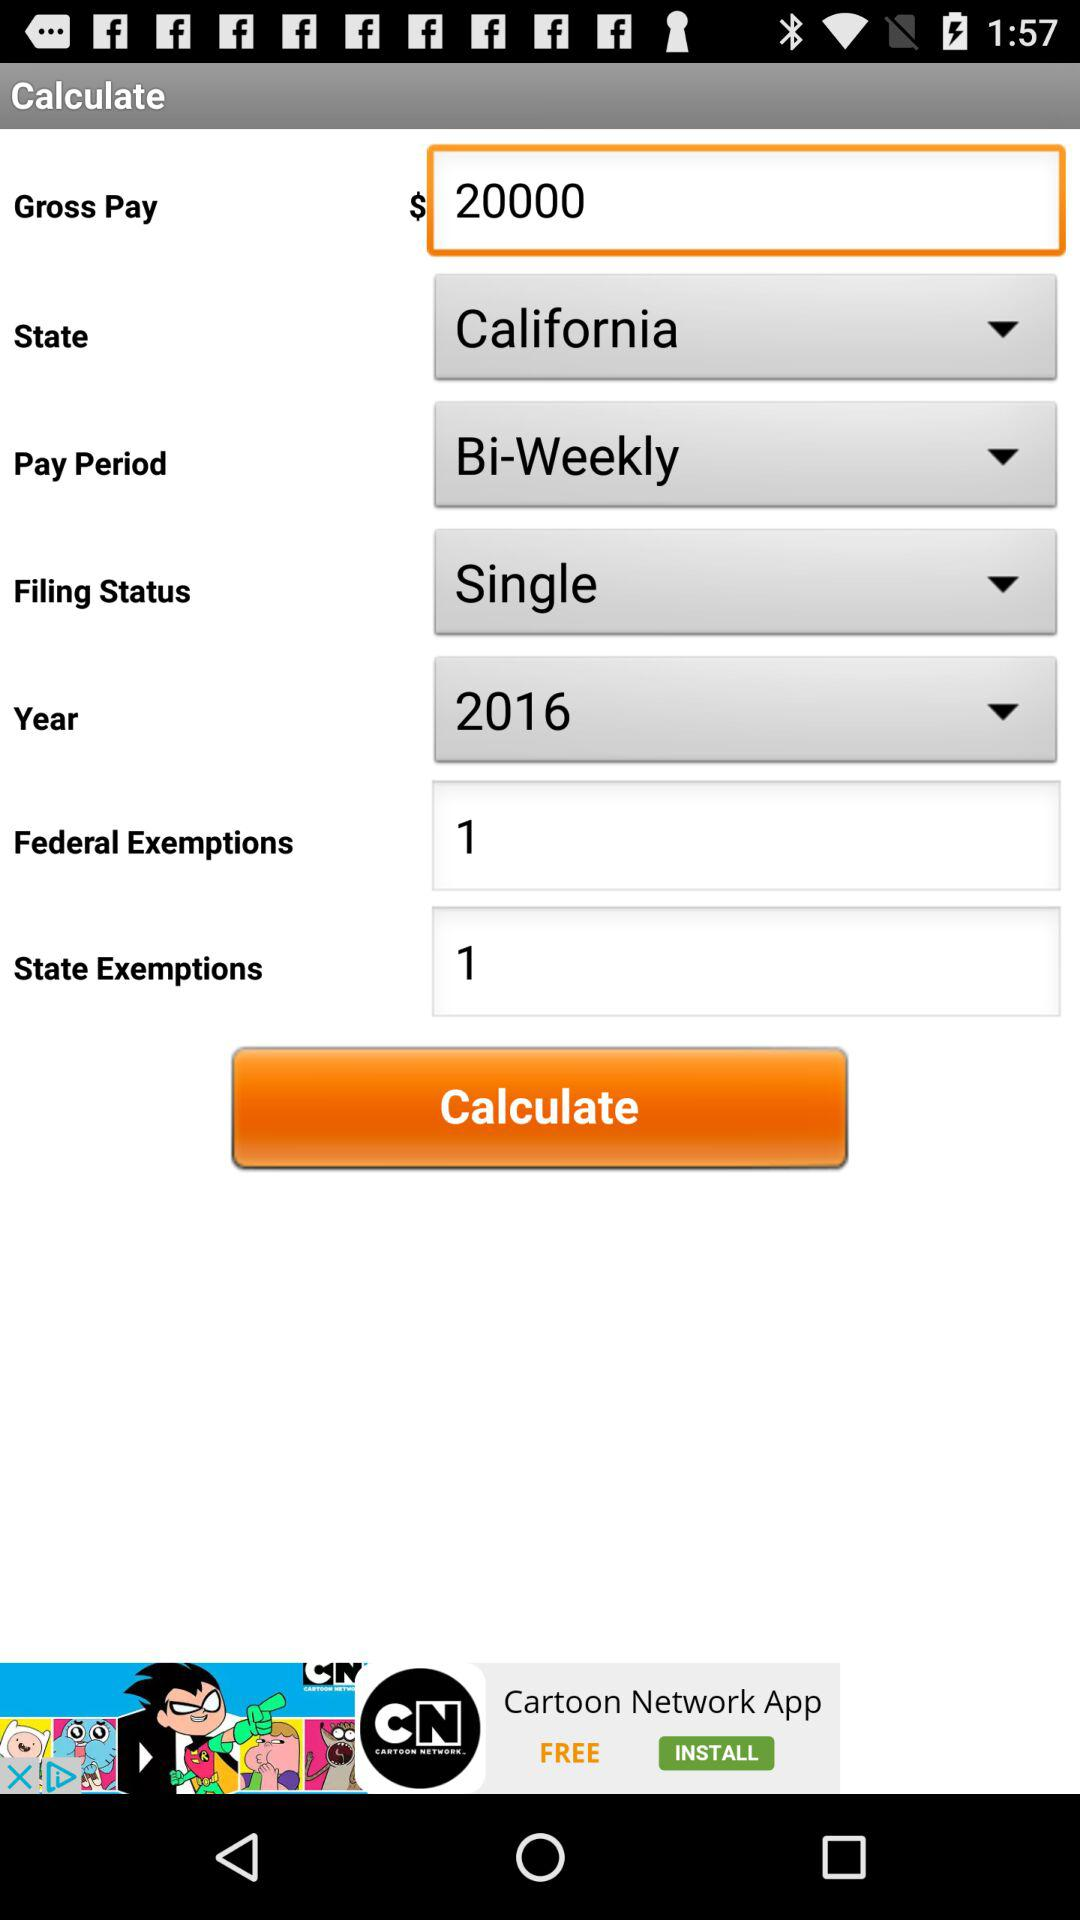How many state exemptions are being claimed?
Answer the question using a single word or phrase. 1 